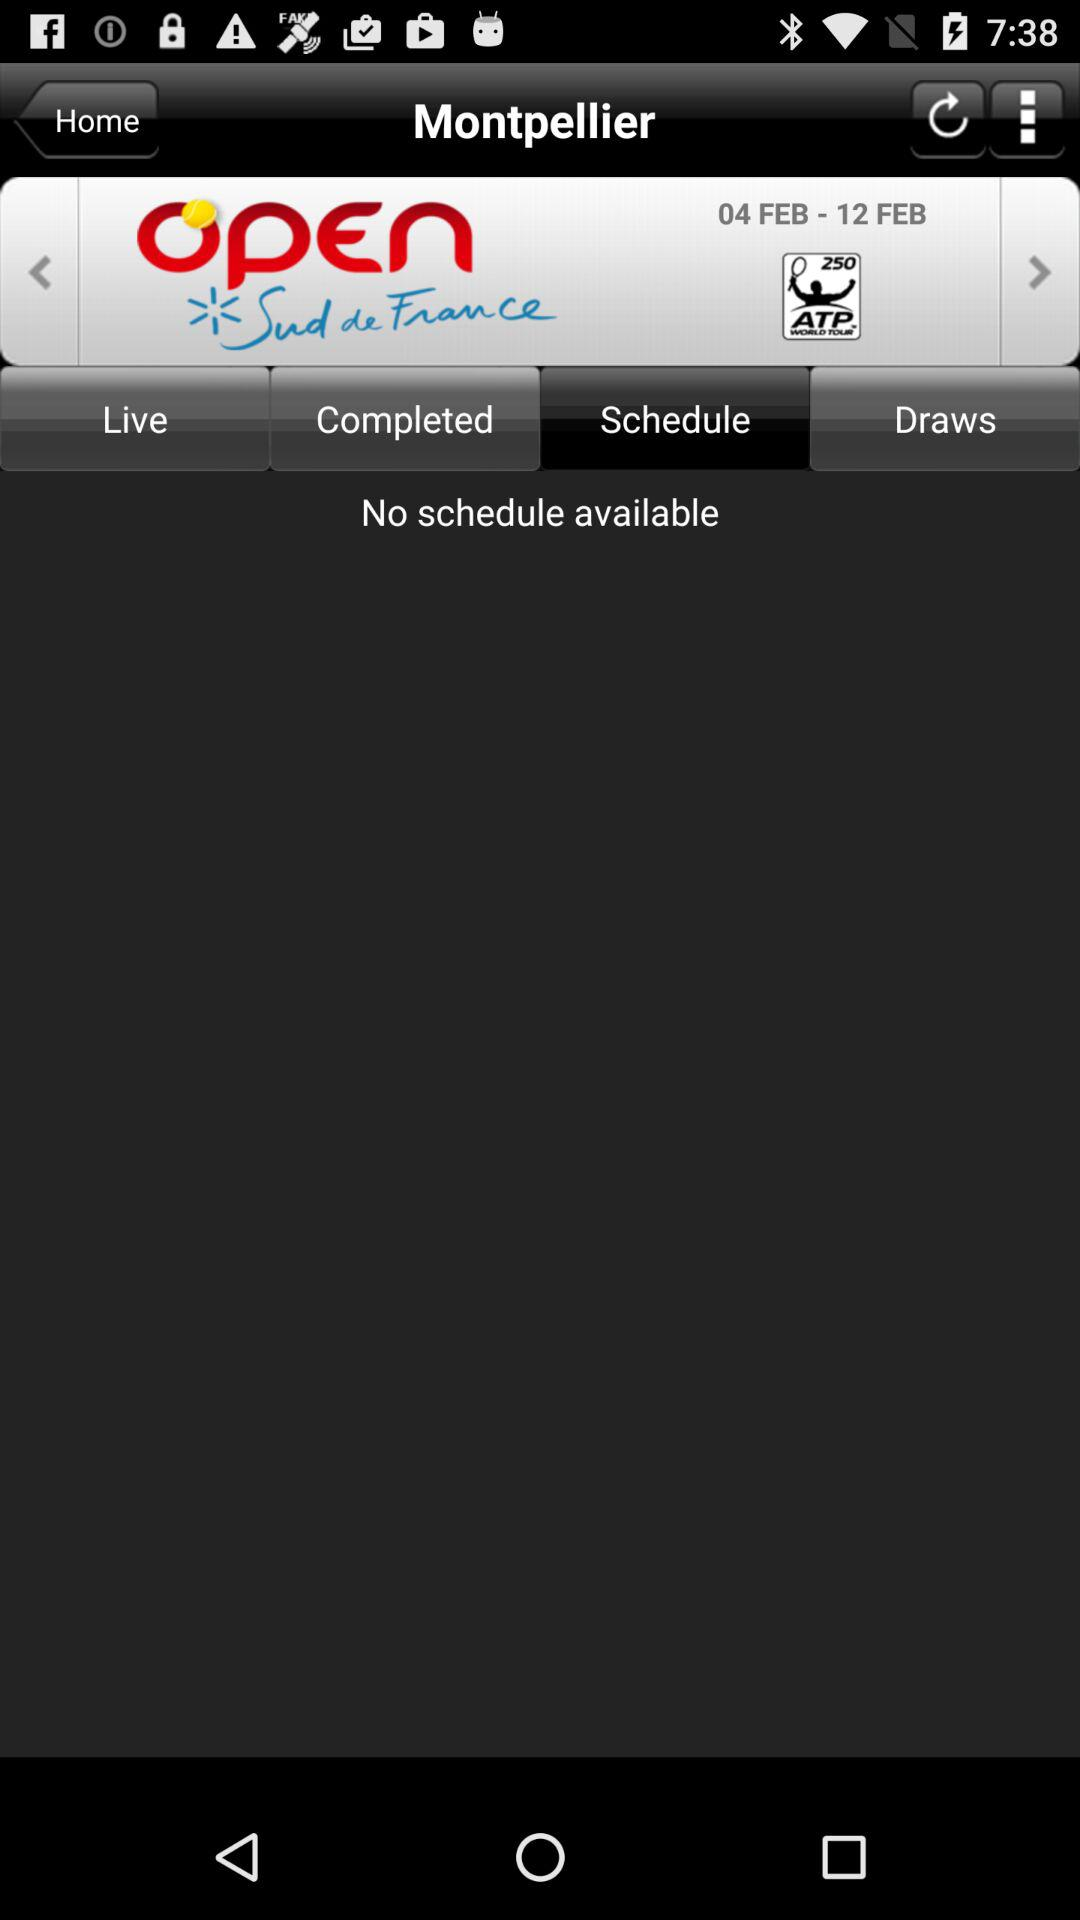Which category of "Montpellier" am I in? You are in the category "Schedule". 